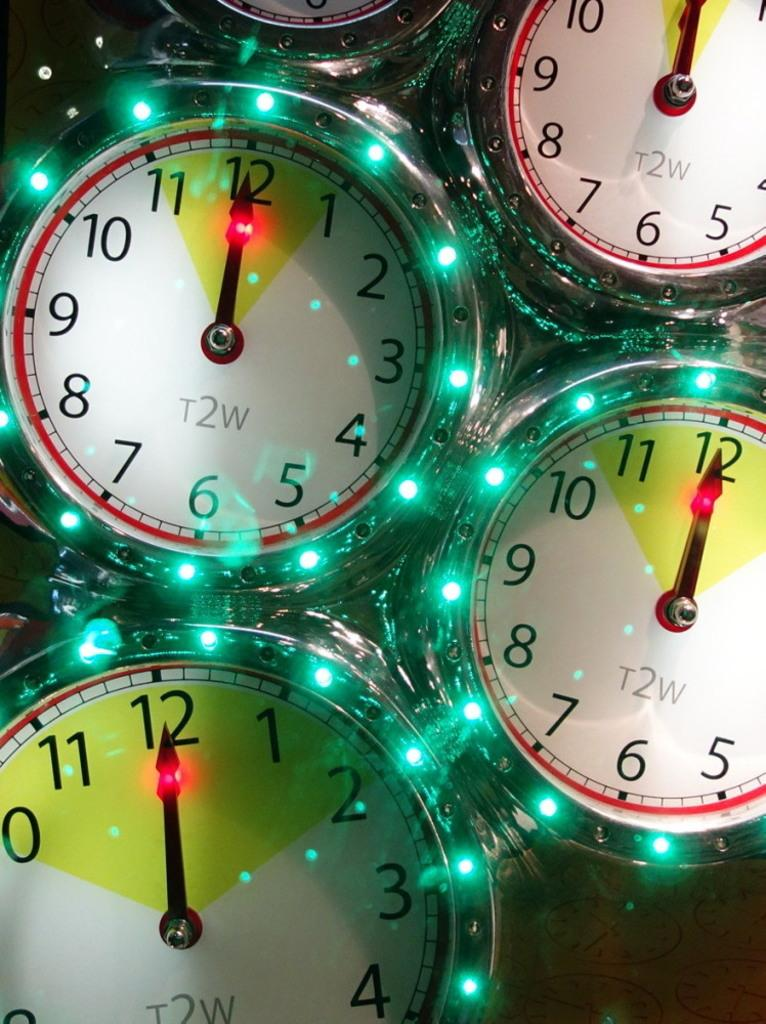<image>
Present a compact description of the photo's key features. All of the clocks in the image read exactly at 12 o'clock. 